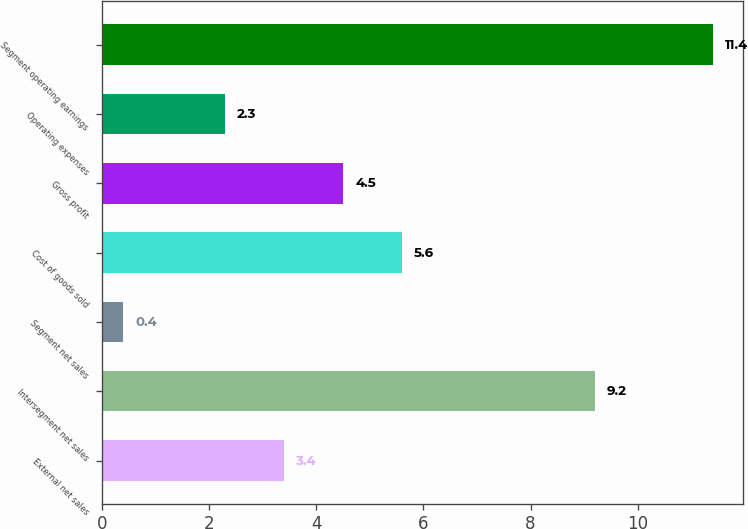<chart> <loc_0><loc_0><loc_500><loc_500><bar_chart><fcel>External net sales<fcel>Intersegment net sales<fcel>Segment net sales<fcel>Cost of goods sold<fcel>Gross profit<fcel>Operating expenses<fcel>Segment operating earnings<nl><fcel>3.4<fcel>9.2<fcel>0.4<fcel>5.6<fcel>4.5<fcel>2.3<fcel>11.4<nl></chart> 